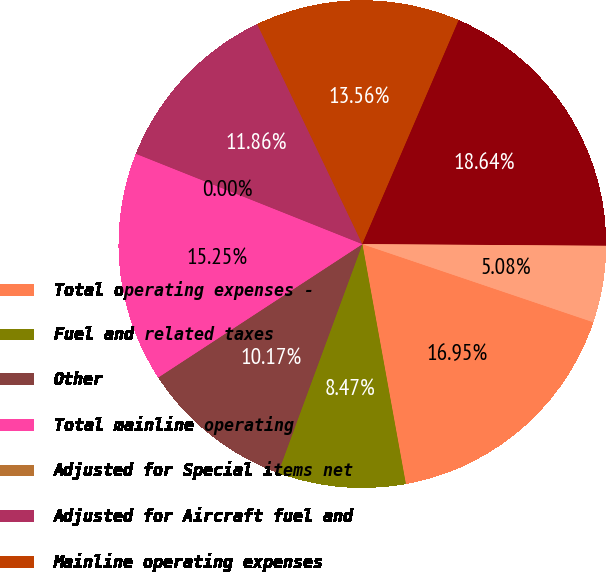Convert chart. <chart><loc_0><loc_0><loc_500><loc_500><pie_chart><fcel>Total operating expenses -<fcel>Fuel and related taxes<fcel>Other<fcel>Total mainline operating<fcel>Adjusted for Special items net<fcel>Adjusted for Aircraft fuel and<fcel>Mainline operating expenses<fcel>Available Seat Miles (ASM)<fcel>Mainline CASM<nl><fcel>16.95%<fcel>8.47%<fcel>10.17%<fcel>15.25%<fcel>0.0%<fcel>11.86%<fcel>13.56%<fcel>18.64%<fcel>5.08%<nl></chart> 